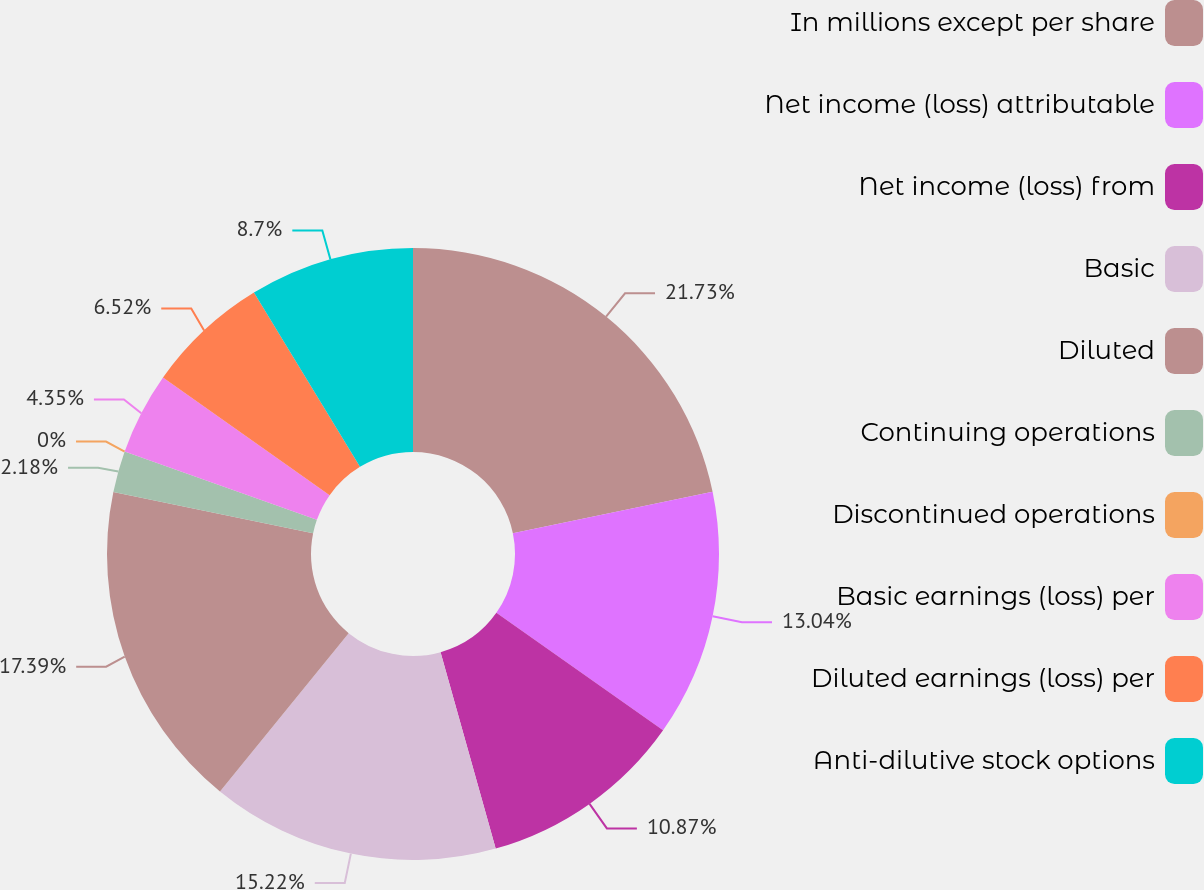Convert chart. <chart><loc_0><loc_0><loc_500><loc_500><pie_chart><fcel>In millions except per share<fcel>Net income (loss) attributable<fcel>Net income (loss) from<fcel>Basic<fcel>Diluted<fcel>Continuing operations<fcel>Discontinued operations<fcel>Basic earnings (loss) per<fcel>Diluted earnings (loss) per<fcel>Anti-dilutive stock options<nl><fcel>21.74%<fcel>13.04%<fcel>10.87%<fcel>15.22%<fcel>17.39%<fcel>2.18%<fcel>0.0%<fcel>4.35%<fcel>6.52%<fcel>8.7%<nl></chart> 